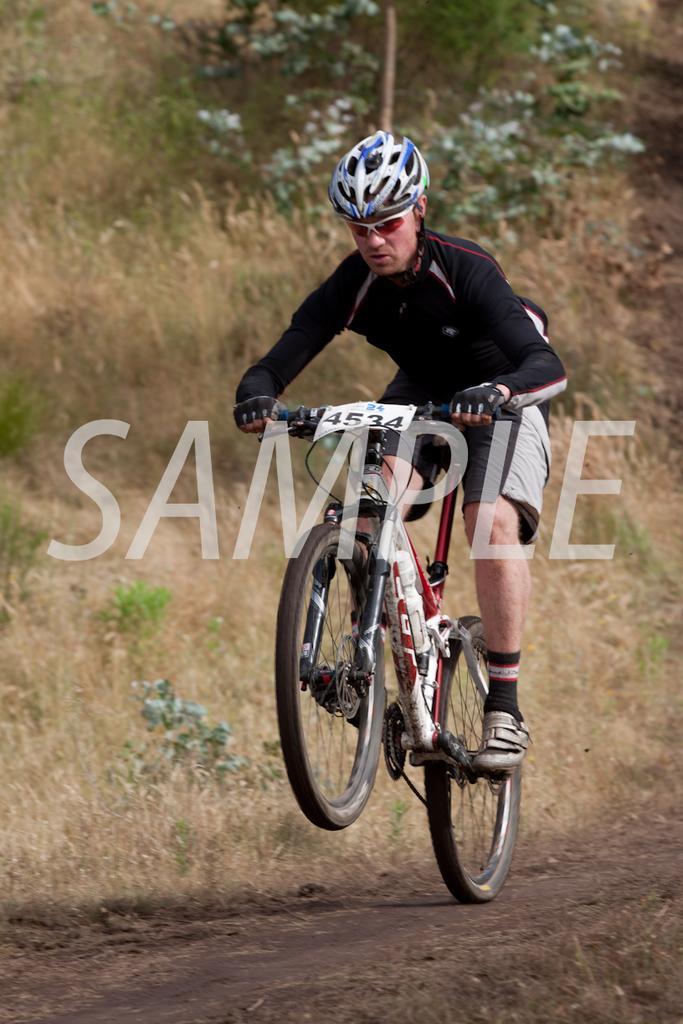Can you describe this image briefly? As we can see in the image there is a man wearing helmet and riding bicycle. There is grass and trees. 